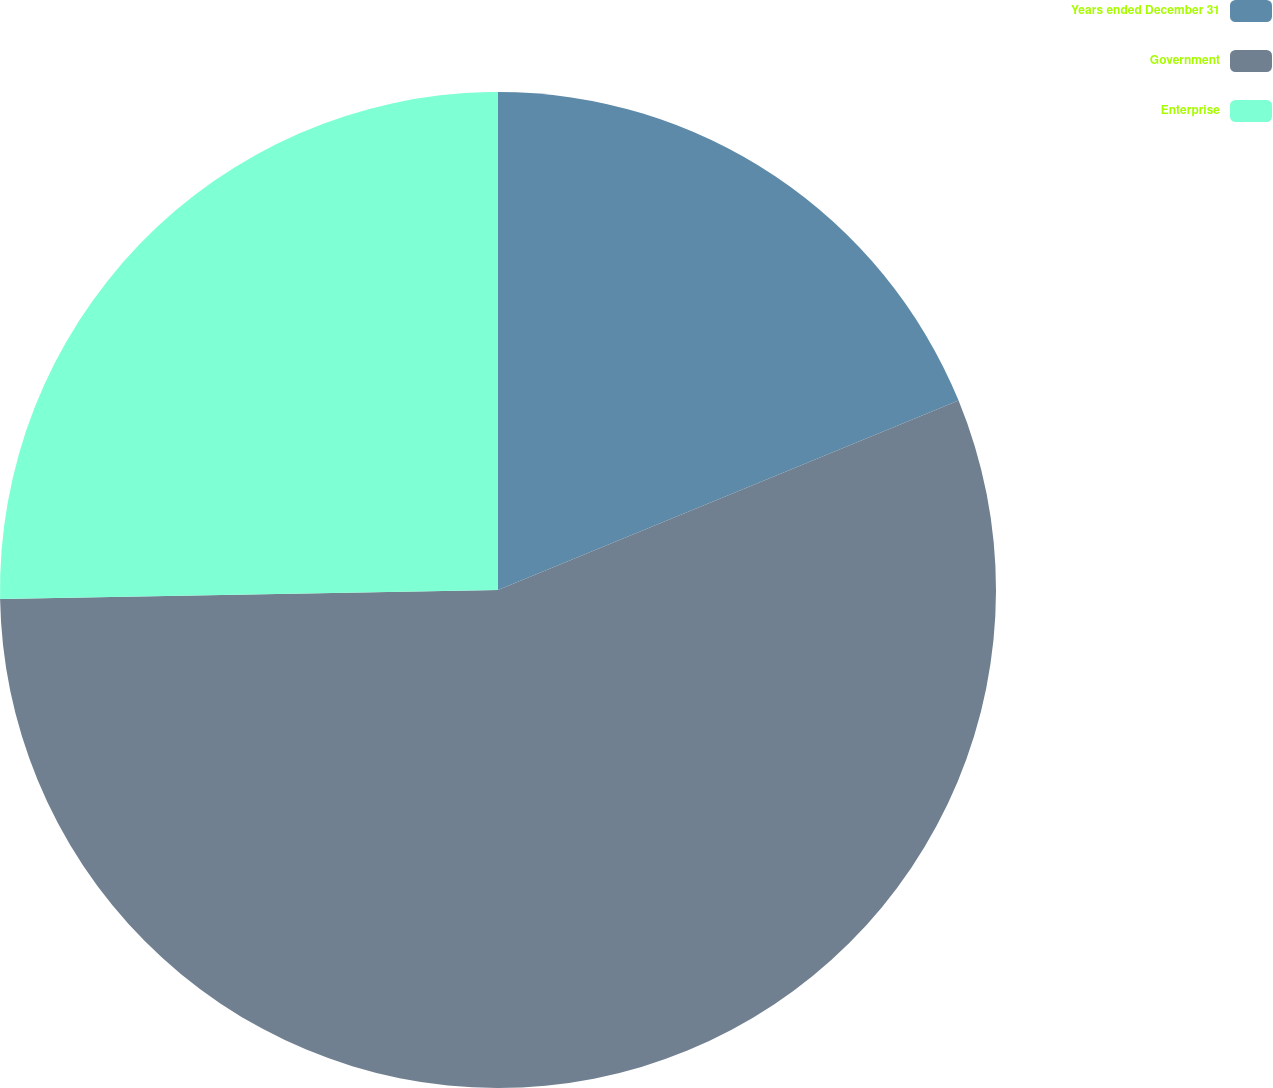<chart> <loc_0><loc_0><loc_500><loc_500><pie_chart><fcel>Years ended December 31<fcel>Government<fcel>Enterprise<nl><fcel>18.79%<fcel>55.92%<fcel>25.29%<nl></chart> 